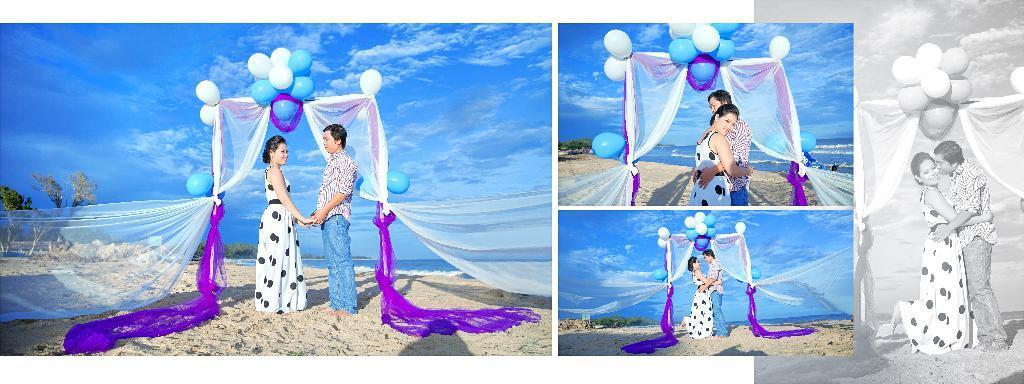Can you describe this image briefly? It is a collage picture. In the image two persons are standing. Behind them there are some clothes and balloons and water. Bottom of the image there is grass. Bottom left side of the image there are some trees. Top of the image there are some clouds and sky. 